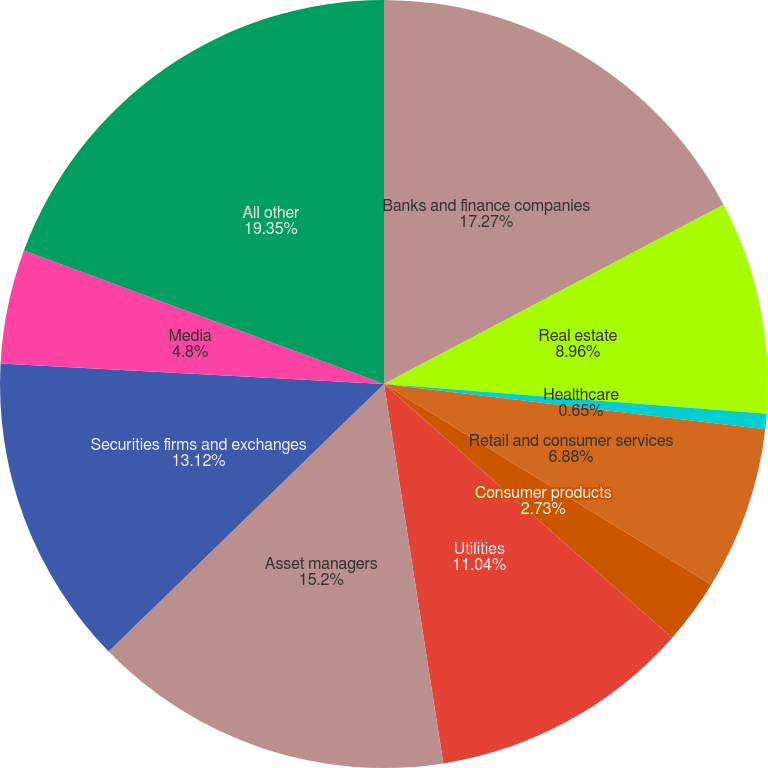Convert chart. <chart><loc_0><loc_0><loc_500><loc_500><pie_chart><fcel>Banks and finance companies<fcel>Real estate<fcel>Healthcare<fcel>Retail and consumer services<fcel>Consumer products<fcel>Utilities<fcel>Asset managers<fcel>Securities firms and exchanges<fcel>Media<fcel>All other<nl><fcel>17.27%<fcel>8.96%<fcel>0.65%<fcel>6.88%<fcel>2.73%<fcel>11.04%<fcel>15.2%<fcel>13.12%<fcel>4.8%<fcel>19.35%<nl></chart> 